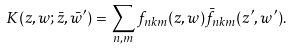Convert formula to latex. <formula><loc_0><loc_0><loc_500><loc_500>K ( z , w ; \bar { z } , \bar { w } ^ { \prime } ) = \sum _ { n , m } f _ { n k m } ( z , w ) \bar { f } _ { n k m } ( z ^ { \prime } , w ^ { \prime } ) .</formula> 